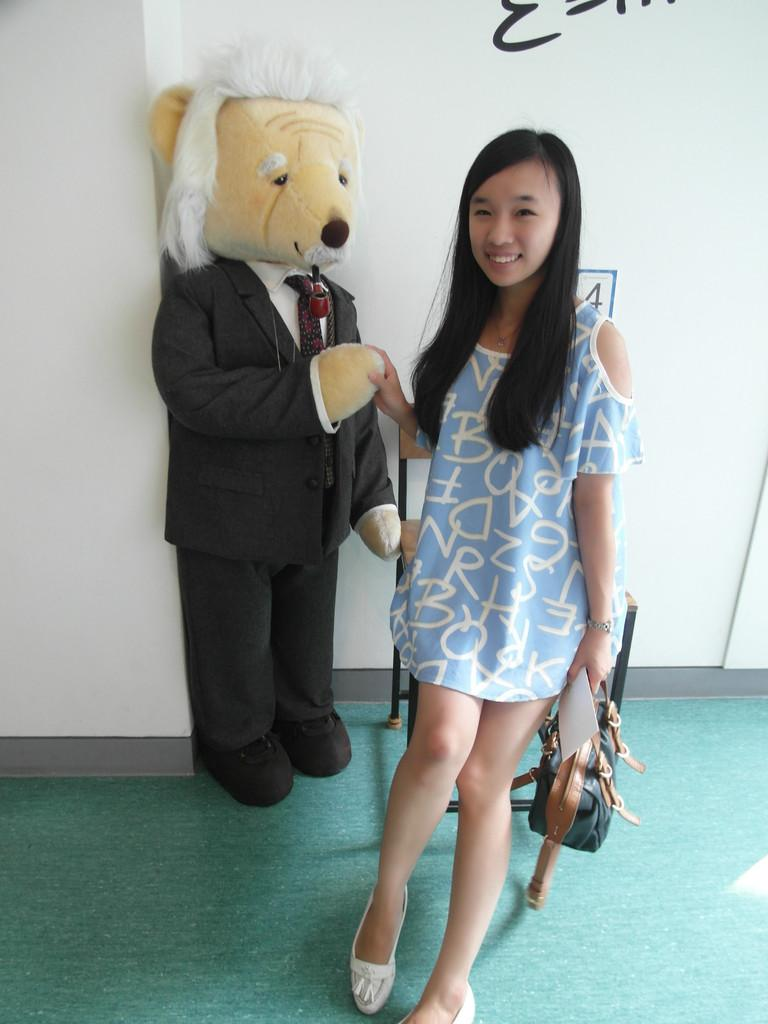Who is the main subject in the image? There is a girl in the image. What is the girl doing in the image? The girl is standing on the ground. What is the girl holding in the image? The girl is holding a bag and some papers. What can be seen in the background of the image? There is a chair, a doll, and text on a wall in the background of the image. Can you see any pictures of the sea in the image? There is no sea or pictures of the sea present in the image. 